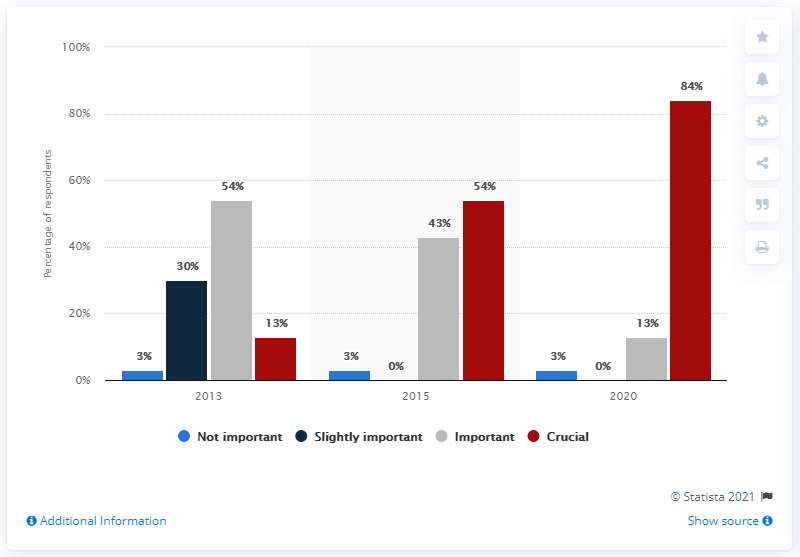Highlight a few significant elements in this photo. The survey shows that digital health strategies are important for pharmaceutical companies as early as 2020. 